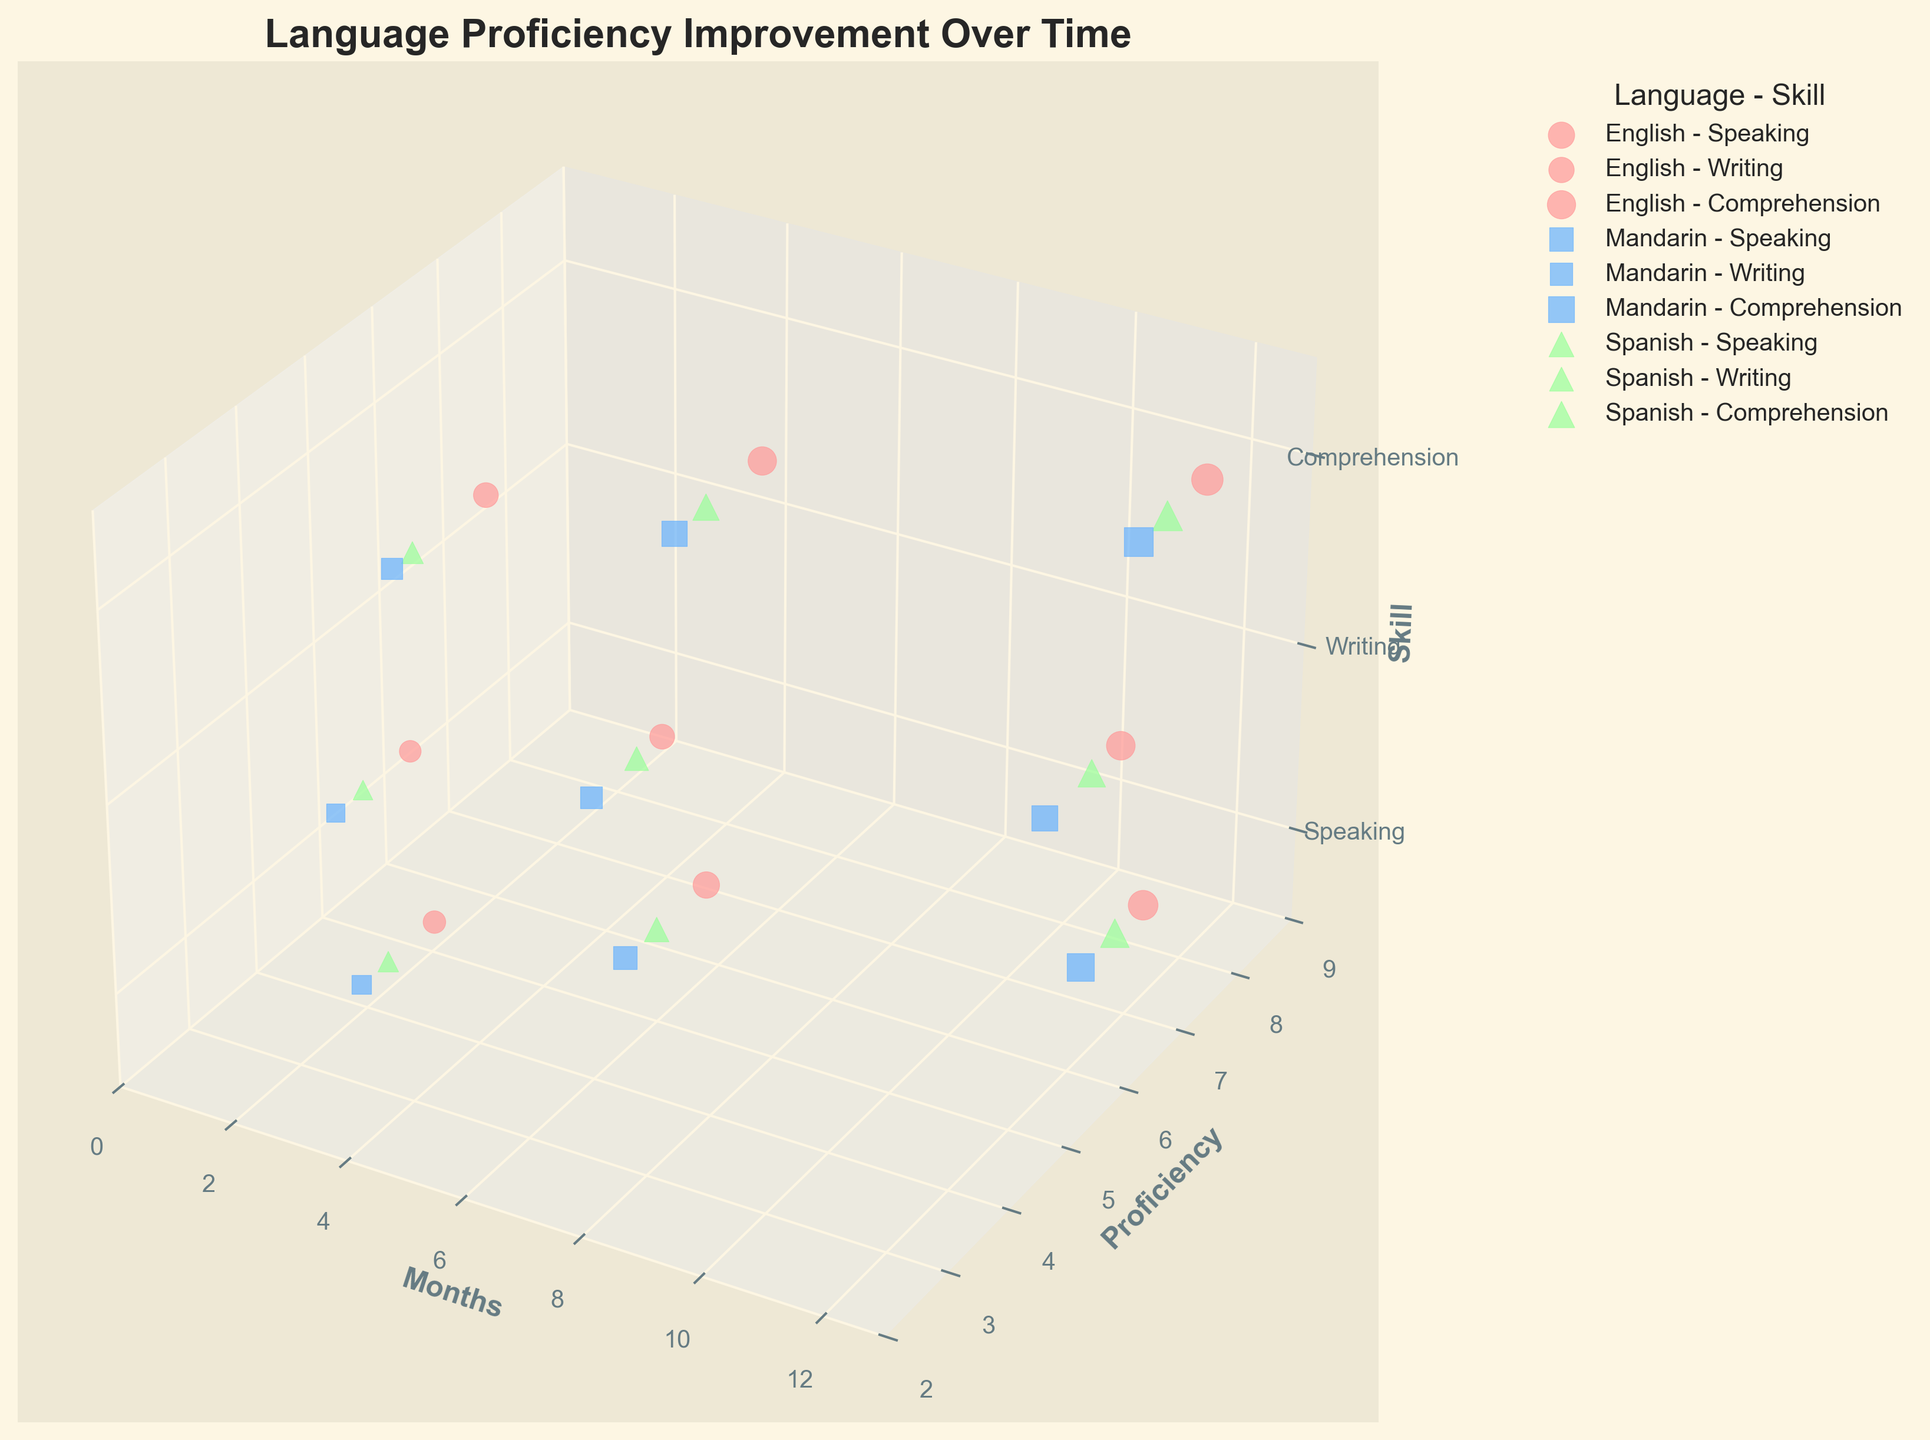How many languages are represented in the figure? By looking at the distinct colors and labels in the legend, we can see English, Mandarin, and Spanish. Hence, there are three languages represented.
Answer: Three What is the title of the figure? The title of the figure is prominently displayed at the top: "Language Proficiency Improvement Over Time."
Answer: Language Proficiency Improvement Over Time Which skill has the highest proficiency for English after 12 months? We look for English data points at the 12-month mark on the z-axis. Speaking is at 7.3, Writing is at 6.8, and Comprehension is at 8.2. Thus, Comprehension has the highest proficiency.
Answer: Comprehension Compare the improvements in writing skills between Mandarin and Spanish. Which language shows a greater increase in proficiency over 12 months? For Mandarin writing, the proficiency goes from 2.8 to 5.5. For Spanish writing, it goes from 3.2 to 6.3. Calculate the differences: Mandarin (5.5 - 2.8 = 2.7) and Spanish (6.3 - 3.2 = 3.1). Spanish shows a greater increase.
Answer: Spanish Between Mandarin speaking and Spanish writing, which has a higher proficiency at 6 months? At 6 months, we compare the Mandarin speaking proficiency (4.5) with the Spanish writing proficiency (4.7). Spanish writing is higher.
Answer: Spanish writing Which language-skill combination shows the largest bubble after 3 months? Larger bubbles are correlated with higher proficiency. At 3 months, check the sizes: English Speaking (4.2), Writing (3.9), Comprehension (5.1), Mandarin Speaking (3.1), Writing (2.8), Comprehension (3.7), Spanish Speaking (3.5), Writing (3.2), Comprehension (4.0). The largest is English Comprehension (5.1).
Answer: English Comprehension What is the average proficiency improvement for English speaking from 3 months to 12 months? Calculate the difference at 12 months and 3 months for English speaking, then find the average. Improvement is 7.3 - 4.2 = 3.1.
Answer: 3.1 How does comprehension proficiency at 12 months compare between all languages? Check comprehension proficiency at 12 months for each language: English (8.2), Mandarin (7.0), Spanish (7.5). English has the highest, followed by Spanish and then Mandarin.
Answer: English > Spanish > Mandarin 